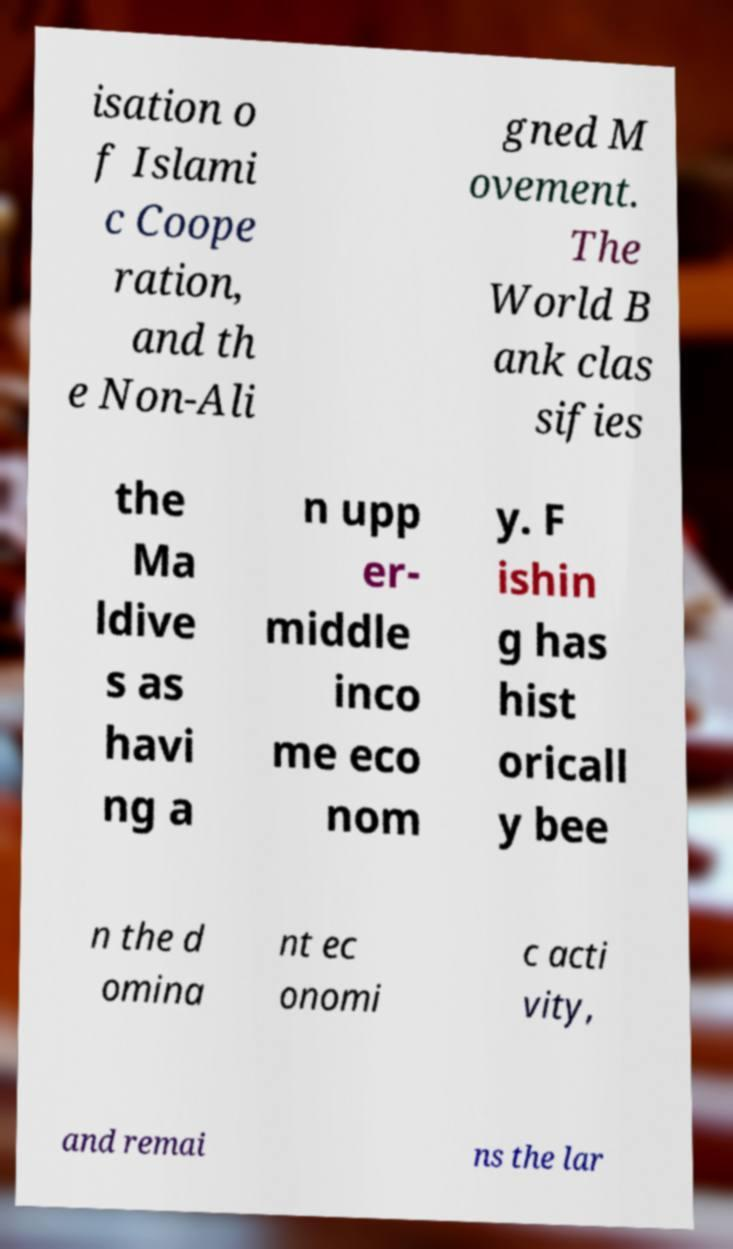Could you assist in decoding the text presented in this image and type it out clearly? isation o f Islami c Coope ration, and th e Non-Ali gned M ovement. The World B ank clas sifies the Ma ldive s as havi ng a n upp er- middle inco me eco nom y. F ishin g has hist oricall y bee n the d omina nt ec onomi c acti vity, and remai ns the lar 